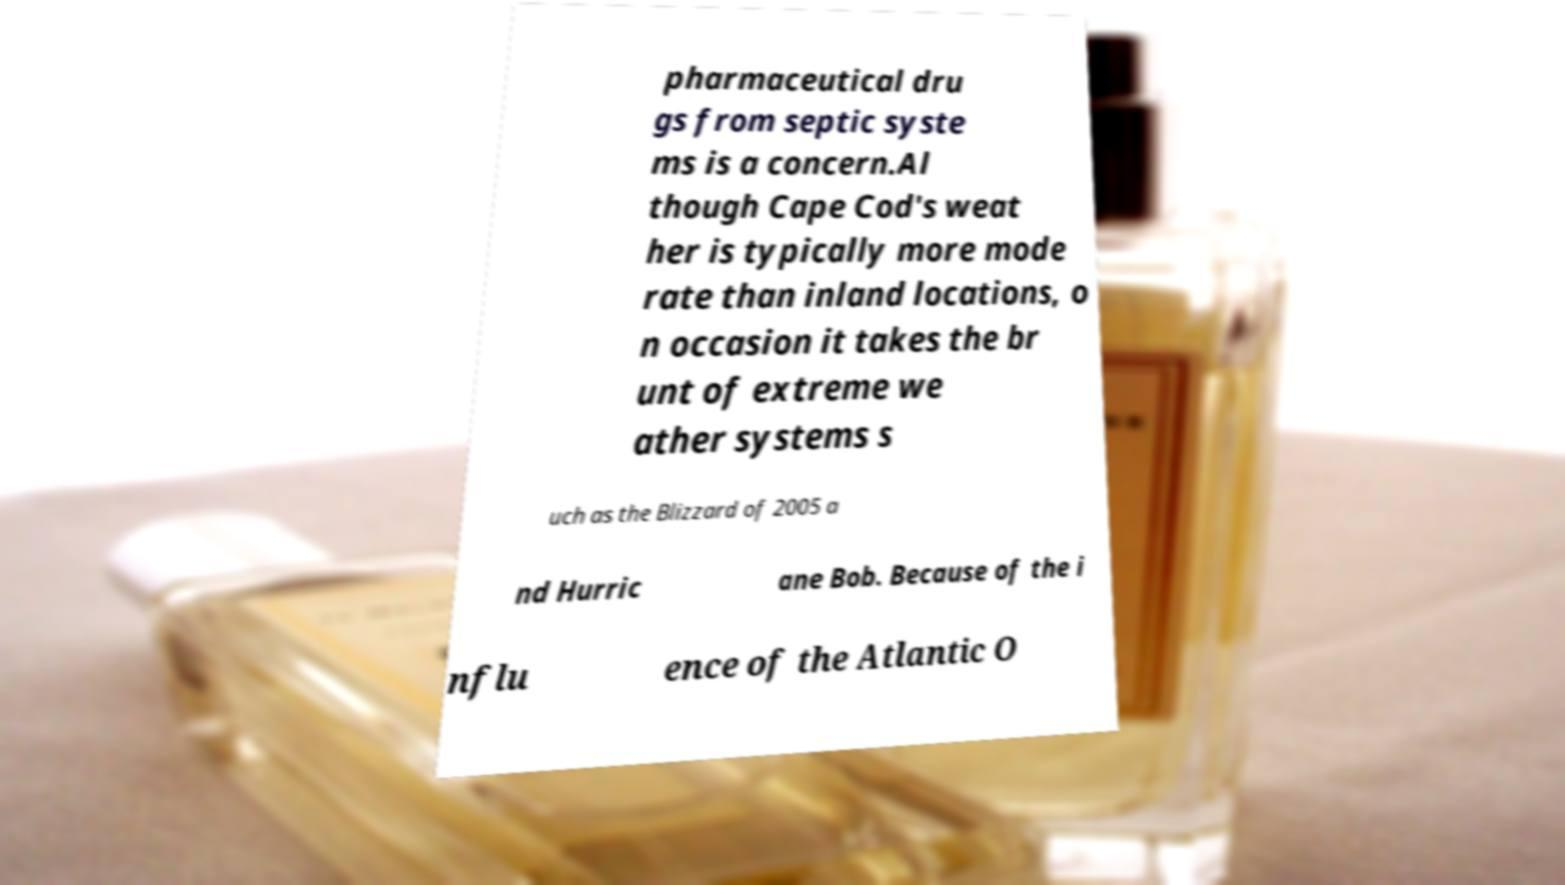Please read and relay the text visible in this image. What does it say? pharmaceutical dru gs from septic syste ms is a concern.Al though Cape Cod's weat her is typically more mode rate than inland locations, o n occasion it takes the br unt of extreme we ather systems s uch as the Blizzard of 2005 a nd Hurric ane Bob. Because of the i nflu ence of the Atlantic O 